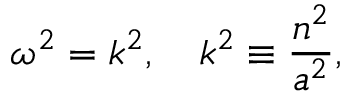Convert formula to latex. <formula><loc_0><loc_0><loc_500><loc_500>\omega ^ { 2 } = k ^ { 2 } , \quad k ^ { 2 } \equiv \frac { n ^ { 2 } } { a ^ { 2 } } ,</formula> 